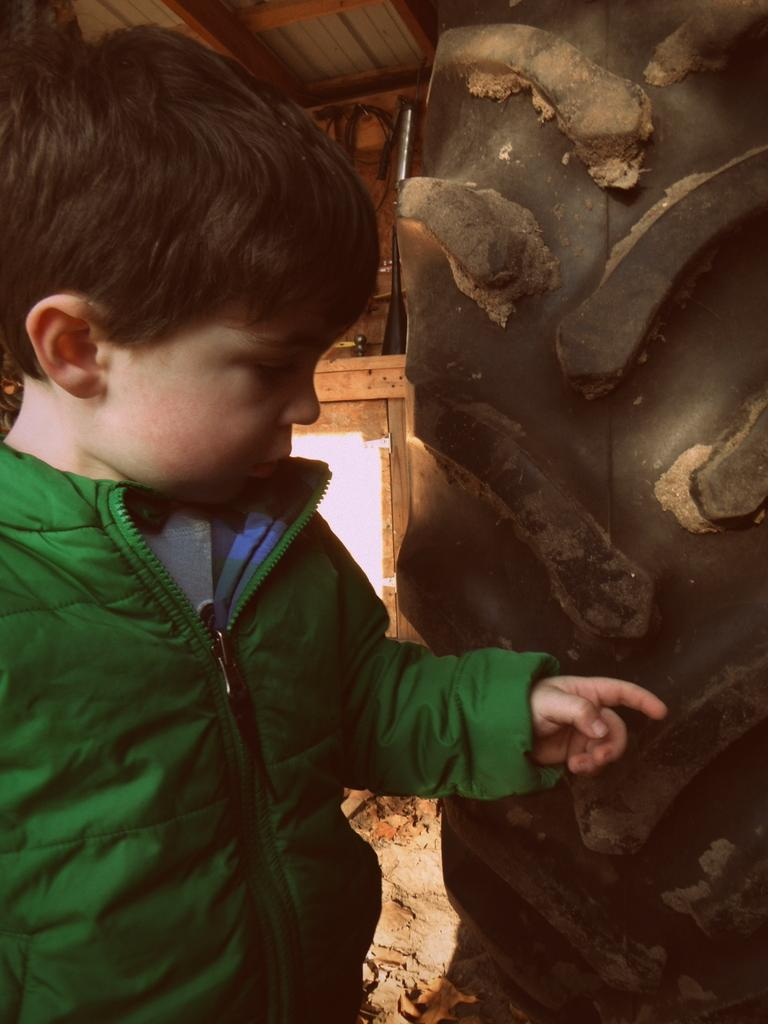Who is present in the image? There is a boy in the image. What is the boy wearing? The boy is wearing a green jacket. What can be seen on the right side of the image? There is a wall on the right side of the image. What type of metal is the baseball bat made of in the image? There is no baseball bat present in the image, so it is not possible to determine the type of metal it might be made of. 